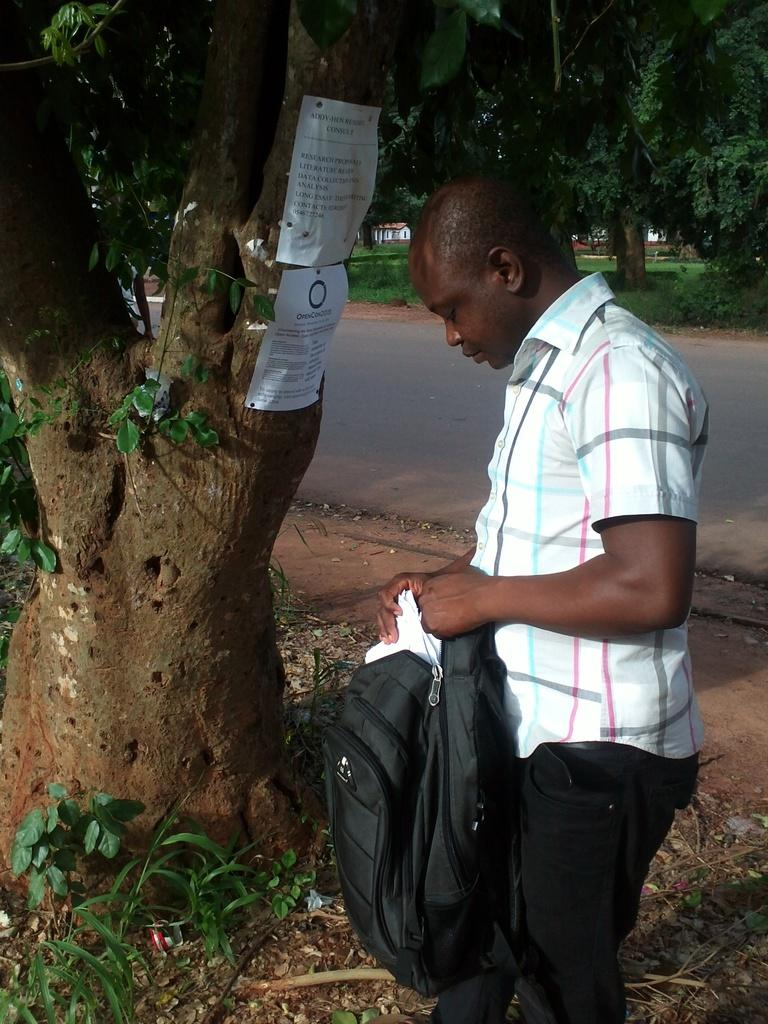What is the man in the image doing? The man is standing in the image. What is the man holding in the image? The man is holding a bag. What type of plant can be seen in the image? There is a tree in the image. What is attached to the tree in the image? There are two papers on the tree. What type of bread can be seen being used to play basketball in the image? There is no bread or basketball present in the image. What type of spark can be seen coming from the man's hand in the image? There is no spark present in the image. 